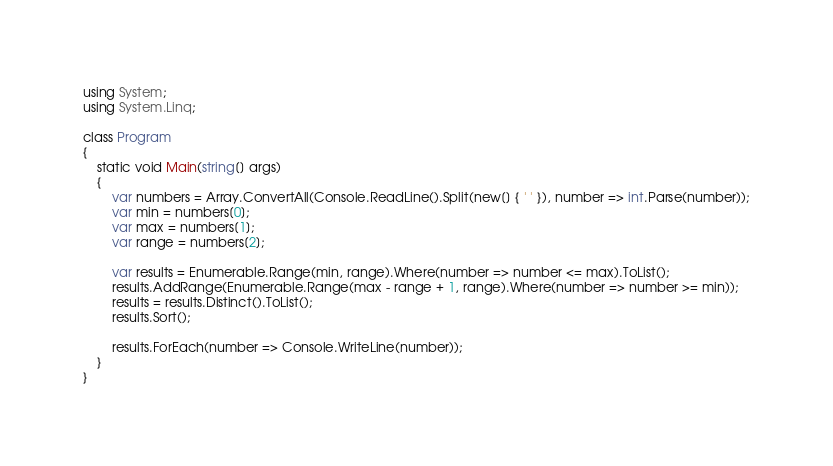<code> <loc_0><loc_0><loc_500><loc_500><_C#_>using System;
using System.Linq;

class Program
{
	static void Main(string[] args)
	{
		var numbers = Array.ConvertAll(Console.ReadLine().Split(new[] { ' ' }), number => int.Parse(number));
		var min = numbers[0];
		var max = numbers[1];
		var range = numbers[2];

		var results = Enumerable.Range(min, range).Where(number => number <= max).ToList();
		results.AddRange(Enumerable.Range(max - range + 1, range).Where(number => number >= min));
		results = results.Distinct().ToList();
		results.Sort();

		results.ForEach(number => Console.WriteLine(number));
	}
}</code> 